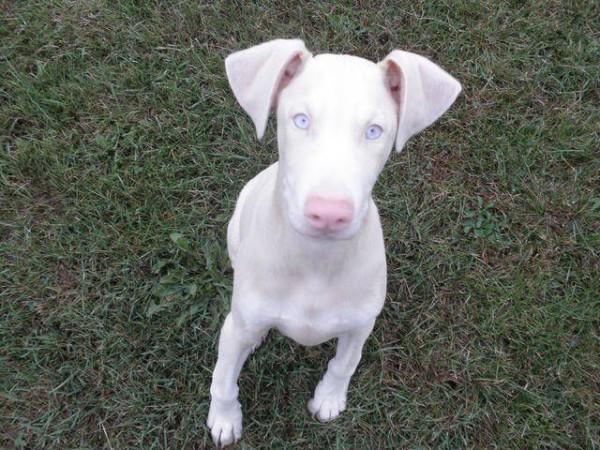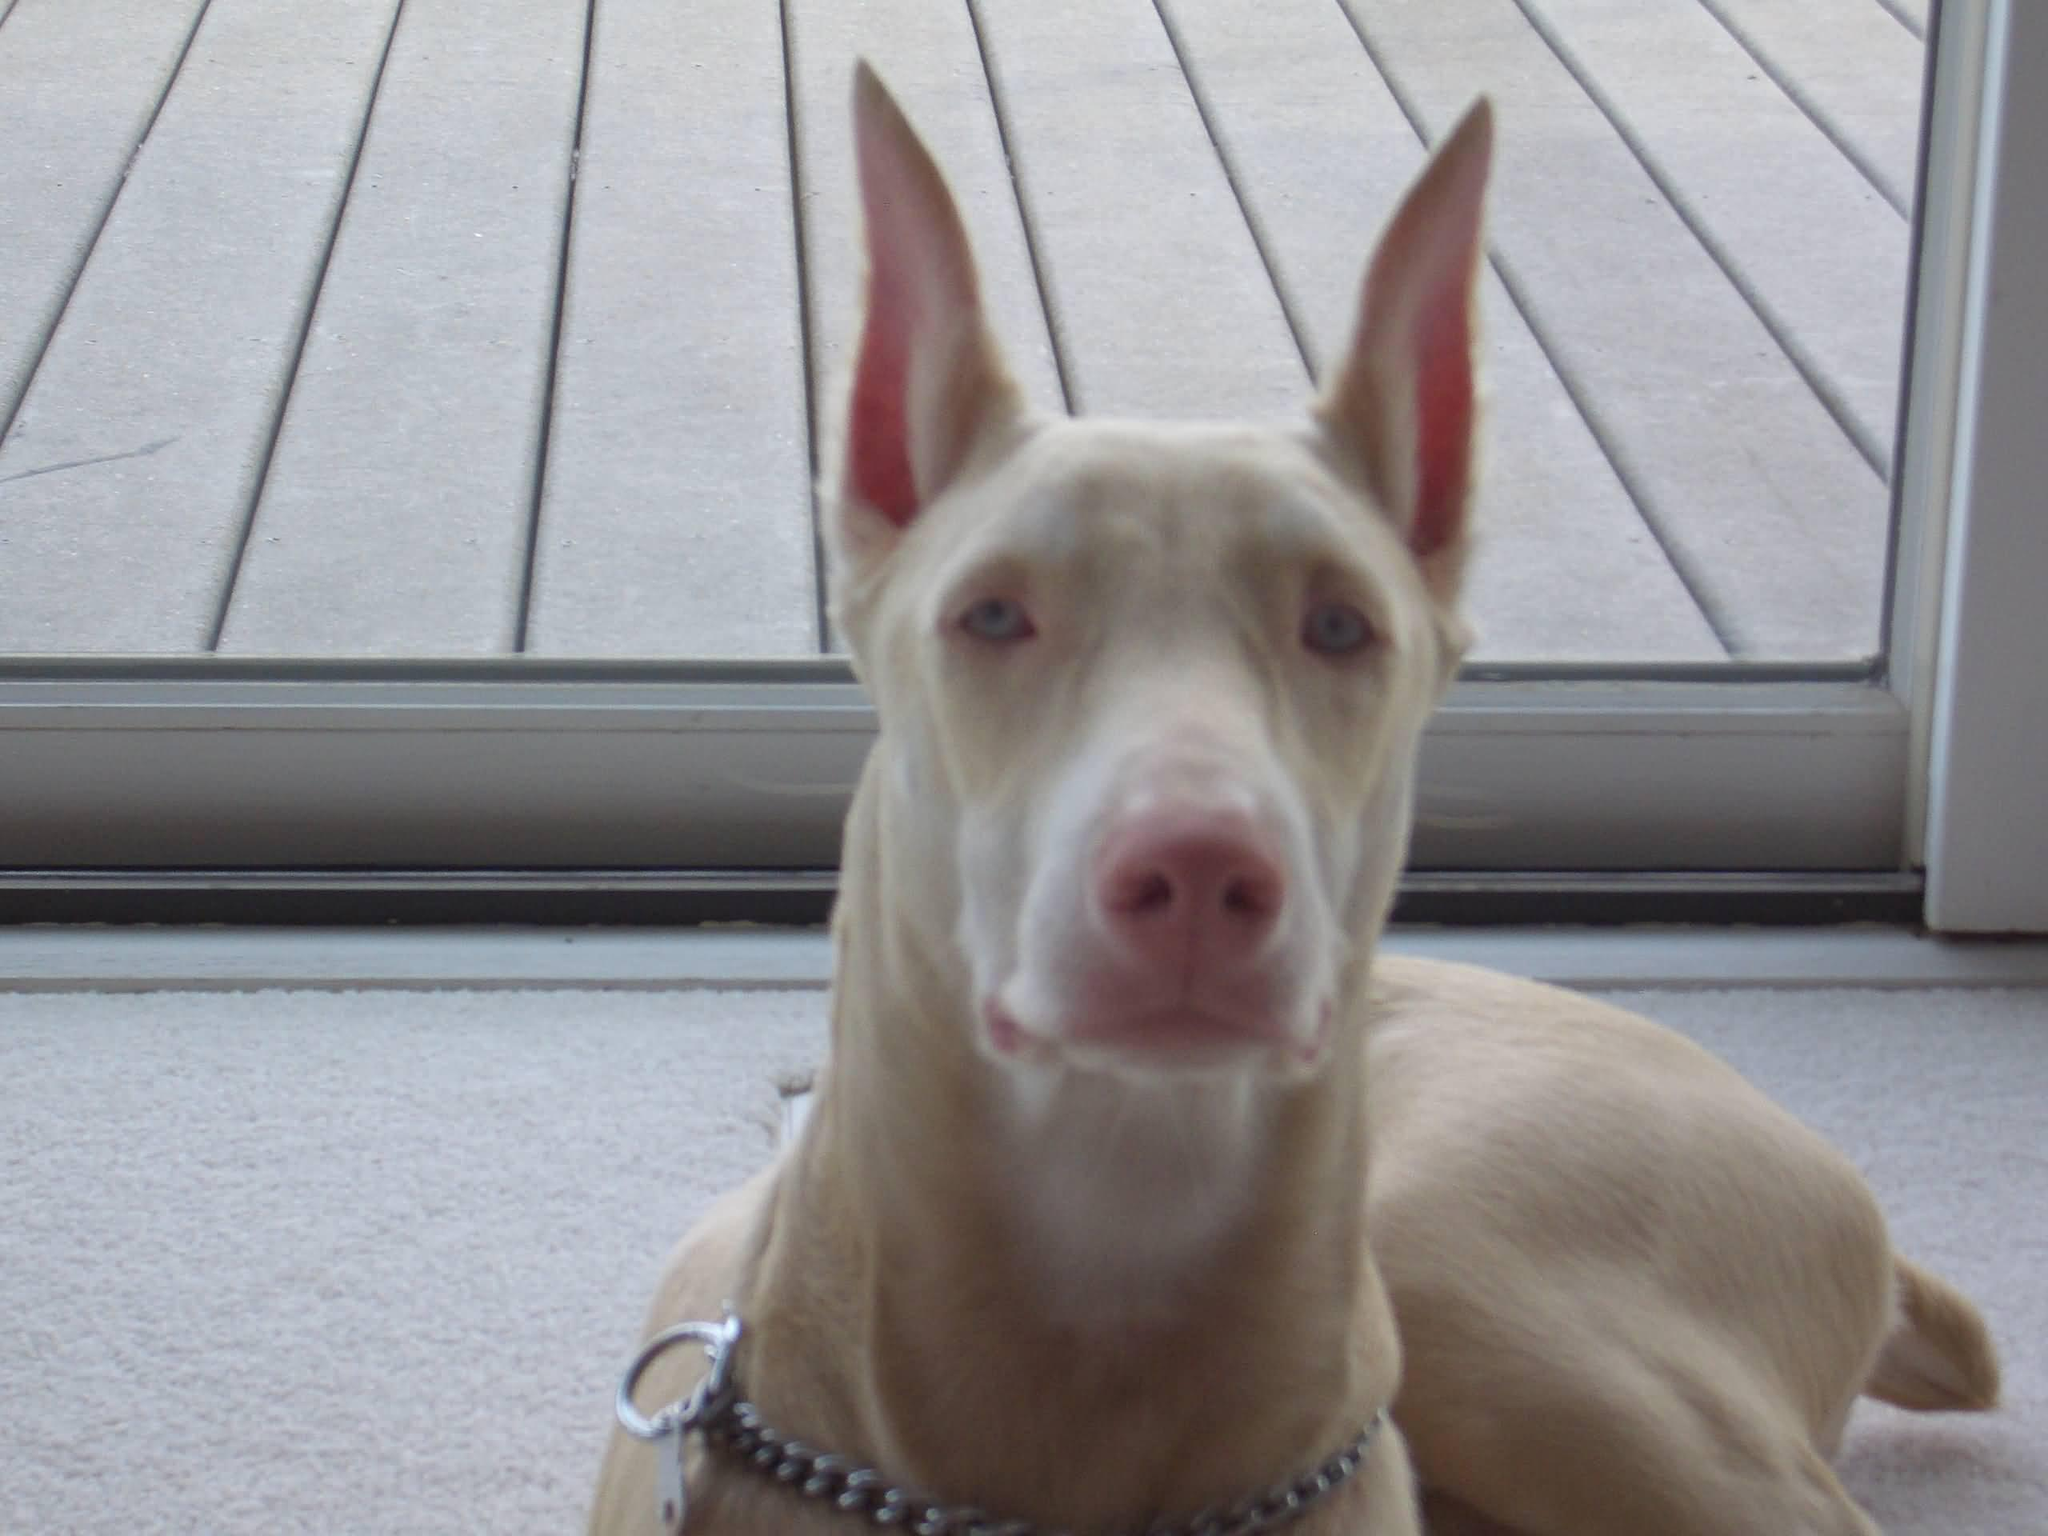The first image is the image on the left, the second image is the image on the right. Examine the images to the left and right. Is the description "There are two dogs with the tips of their ears pointed up" accurate? Answer yes or no. No. The first image is the image on the left, the second image is the image on the right. For the images shown, is this caption "The ears of the dog in one of the images are down." true? Answer yes or no. Yes. 